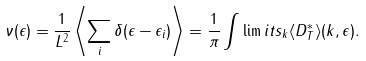Convert formula to latex. <formula><loc_0><loc_0><loc_500><loc_500>\nu ( \epsilon ) = \frac { 1 } { L ^ { 2 } } \left \langle \sum _ { i } \delta ( \epsilon - \epsilon _ { i } ) \right \rangle = \frac { 1 } { \pi } \int \lim i t s _ { k } \langle { D } ^ { * } _ { T } \rangle ( { k } , \epsilon ) .</formula> 